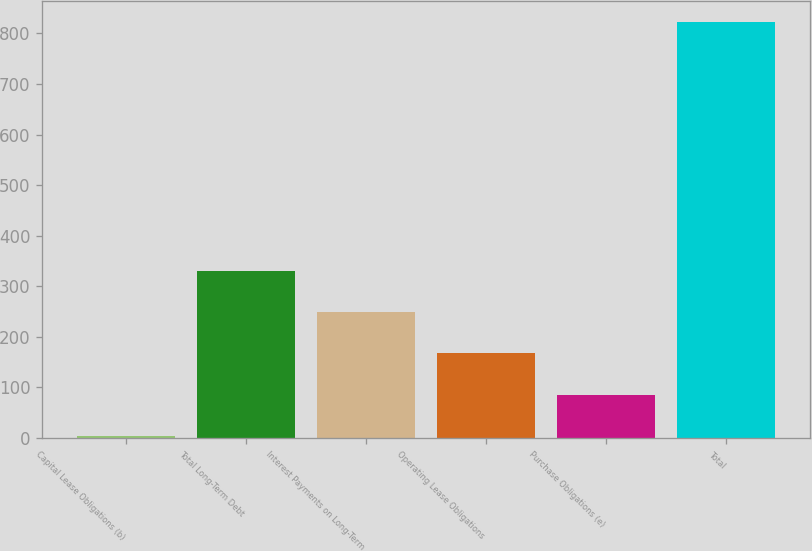Convert chart to OTSL. <chart><loc_0><loc_0><loc_500><loc_500><bar_chart><fcel>Capital Lease Obligations (b)<fcel>Total Long-Term Debt<fcel>Interest Payments on Long-Term<fcel>Operating Lease Obligations<fcel>Purchase Obligations (e)<fcel>Total<nl><fcel>3<fcel>331.04<fcel>249.03<fcel>167.02<fcel>85.01<fcel>823.1<nl></chart> 